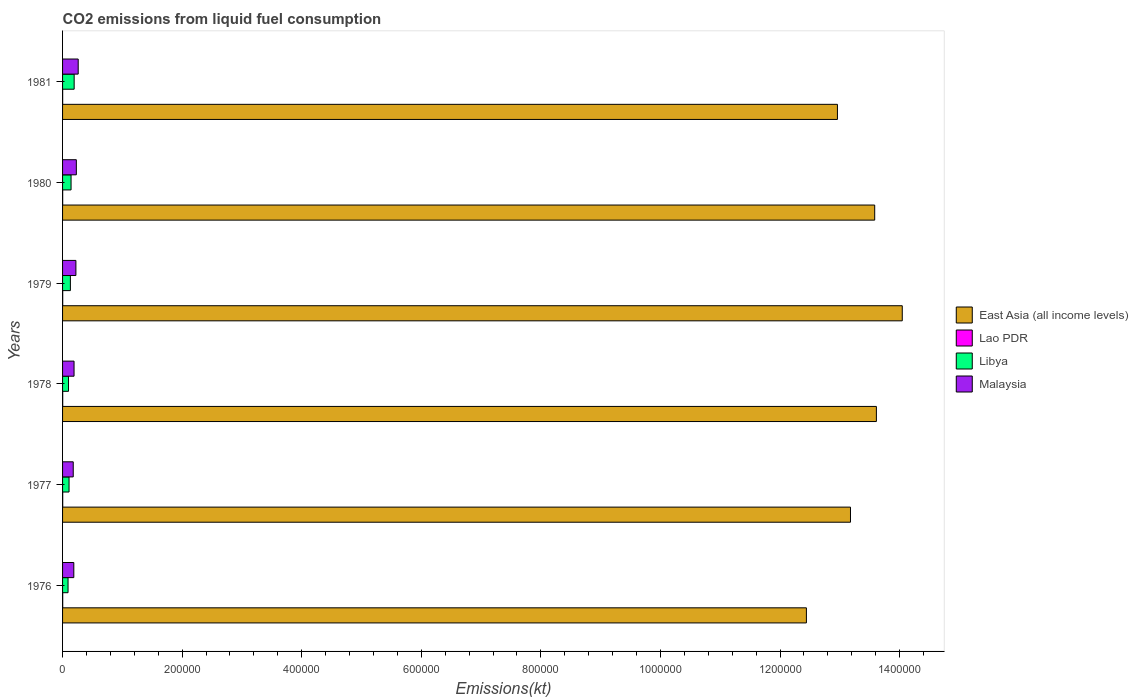How many groups of bars are there?
Ensure brevity in your answer.  6. Are the number of bars per tick equal to the number of legend labels?
Offer a very short reply. Yes. How many bars are there on the 4th tick from the top?
Ensure brevity in your answer.  4. What is the label of the 5th group of bars from the top?
Give a very brief answer. 1977. What is the amount of CO2 emitted in Malaysia in 1981?
Your response must be concise. 2.61e+04. Across all years, what is the maximum amount of CO2 emitted in Malaysia?
Ensure brevity in your answer.  2.61e+04. Across all years, what is the minimum amount of CO2 emitted in East Asia (all income levels)?
Make the answer very short. 1.24e+06. In which year was the amount of CO2 emitted in Libya maximum?
Offer a terse response. 1981. In which year was the amount of CO2 emitted in Libya minimum?
Provide a short and direct response. 1976. What is the total amount of CO2 emitted in Libya in the graph?
Provide a short and direct response. 7.66e+04. What is the difference between the amount of CO2 emitted in Malaysia in 1976 and that in 1981?
Provide a succinct answer. -7330.33. What is the difference between the amount of CO2 emitted in East Asia (all income levels) in 1981 and the amount of CO2 emitted in Lao PDR in 1980?
Offer a very short reply. 1.30e+06. What is the average amount of CO2 emitted in Malaysia per year?
Your answer should be very brief. 2.12e+04. In the year 1977, what is the difference between the amount of CO2 emitted in Libya and amount of CO2 emitted in Lao PDR?
Offer a very short reply. 1.06e+04. In how many years, is the amount of CO2 emitted in East Asia (all income levels) greater than 480000 kt?
Make the answer very short. 6. What is the ratio of the amount of CO2 emitted in Libya in 1977 to that in 1979?
Keep it short and to the point. 0.83. Is the difference between the amount of CO2 emitted in Libya in 1976 and 1980 greater than the difference between the amount of CO2 emitted in Lao PDR in 1976 and 1980?
Make the answer very short. No. What is the difference between the highest and the lowest amount of CO2 emitted in Lao PDR?
Provide a succinct answer. 80.67. In how many years, is the amount of CO2 emitted in Lao PDR greater than the average amount of CO2 emitted in Lao PDR taken over all years?
Your answer should be compact. 4. Is it the case that in every year, the sum of the amount of CO2 emitted in East Asia (all income levels) and amount of CO2 emitted in Malaysia is greater than the sum of amount of CO2 emitted in Libya and amount of CO2 emitted in Lao PDR?
Your answer should be very brief. Yes. What does the 3rd bar from the top in 1979 represents?
Ensure brevity in your answer.  Lao PDR. What does the 2nd bar from the bottom in 1978 represents?
Provide a succinct answer. Lao PDR. Is it the case that in every year, the sum of the amount of CO2 emitted in Malaysia and amount of CO2 emitted in Libya is greater than the amount of CO2 emitted in East Asia (all income levels)?
Your response must be concise. No. Does the graph contain grids?
Your response must be concise. No. Where does the legend appear in the graph?
Offer a terse response. Center right. What is the title of the graph?
Your answer should be very brief. CO2 emissions from liquid fuel consumption. What is the label or title of the X-axis?
Provide a short and direct response. Emissions(kt). What is the Emissions(kt) in East Asia (all income levels) in 1976?
Keep it short and to the point. 1.24e+06. What is the Emissions(kt) of Lao PDR in 1976?
Provide a short and direct response. 223.69. What is the Emissions(kt) of Libya in 1976?
Provide a succinct answer. 9160.17. What is the Emissions(kt) in Malaysia in 1976?
Your answer should be compact. 1.88e+04. What is the Emissions(kt) of East Asia (all income levels) in 1977?
Provide a succinct answer. 1.32e+06. What is the Emissions(kt) in Lao PDR in 1977?
Your response must be concise. 231.02. What is the Emissions(kt) in Libya in 1977?
Make the answer very short. 1.08e+04. What is the Emissions(kt) in Malaysia in 1977?
Offer a terse response. 1.78e+04. What is the Emissions(kt) of East Asia (all income levels) in 1978?
Give a very brief answer. 1.36e+06. What is the Emissions(kt) of Lao PDR in 1978?
Give a very brief answer. 231.02. What is the Emissions(kt) in Libya in 1978?
Your answer should be very brief. 9952.24. What is the Emissions(kt) in Malaysia in 1978?
Your answer should be compact. 1.92e+04. What is the Emissions(kt) in East Asia (all income levels) in 1979?
Your response must be concise. 1.40e+06. What is the Emissions(kt) in Lao PDR in 1979?
Provide a short and direct response. 223.69. What is the Emissions(kt) of Libya in 1979?
Ensure brevity in your answer.  1.31e+04. What is the Emissions(kt) of Malaysia in 1979?
Your response must be concise. 2.23e+04. What is the Emissions(kt) of East Asia (all income levels) in 1980?
Provide a short and direct response. 1.36e+06. What is the Emissions(kt) of Lao PDR in 1980?
Provide a succinct answer. 187.02. What is the Emissions(kt) of Libya in 1980?
Offer a very short reply. 1.42e+04. What is the Emissions(kt) of Malaysia in 1980?
Provide a succinct answer. 2.30e+04. What is the Emissions(kt) of East Asia (all income levels) in 1981?
Your answer should be compact. 1.30e+06. What is the Emissions(kt) of Lao PDR in 1981?
Your response must be concise. 150.35. What is the Emissions(kt) of Libya in 1981?
Give a very brief answer. 1.94e+04. What is the Emissions(kt) of Malaysia in 1981?
Make the answer very short. 2.61e+04. Across all years, what is the maximum Emissions(kt) of East Asia (all income levels)?
Give a very brief answer. 1.40e+06. Across all years, what is the maximum Emissions(kt) of Lao PDR?
Your answer should be very brief. 231.02. Across all years, what is the maximum Emissions(kt) in Libya?
Offer a very short reply. 1.94e+04. Across all years, what is the maximum Emissions(kt) of Malaysia?
Your answer should be compact. 2.61e+04. Across all years, what is the minimum Emissions(kt) in East Asia (all income levels)?
Offer a very short reply. 1.24e+06. Across all years, what is the minimum Emissions(kt) of Lao PDR?
Provide a succinct answer. 150.35. Across all years, what is the minimum Emissions(kt) of Libya?
Keep it short and to the point. 9160.17. Across all years, what is the minimum Emissions(kt) in Malaysia?
Provide a short and direct response. 1.78e+04. What is the total Emissions(kt) of East Asia (all income levels) in the graph?
Make the answer very short. 7.98e+06. What is the total Emissions(kt) in Lao PDR in the graph?
Your answer should be very brief. 1246.78. What is the total Emissions(kt) of Libya in the graph?
Your answer should be compact. 7.66e+04. What is the total Emissions(kt) of Malaysia in the graph?
Provide a short and direct response. 1.27e+05. What is the difference between the Emissions(kt) of East Asia (all income levels) in 1976 and that in 1977?
Provide a short and direct response. -7.37e+04. What is the difference between the Emissions(kt) of Lao PDR in 1976 and that in 1977?
Your answer should be very brief. -7.33. What is the difference between the Emissions(kt) of Libya in 1976 and that in 1977?
Your answer should be compact. -1668.48. What is the difference between the Emissions(kt) in Malaysia in 1976 and that in 1977?
Make the answer very short. 975.42. What is the difference between the Emissions(kt) in East Asia (all income levels) in 1976 and that in 1978?
Provide a succinct answer. -1.17e+05. What is the difference between the Emissions(kt) of Lao PDR in 1976 and that in 1978?
Offer a terse response. -7.33. What is the difference between the Emissions(kt) in Libya in 1976 and that in 1978?
Provide a succinct answer. -792.07. What is the difference between the Emissions(kt) of Malaysia in 1976 and that in 1978?
Your response must be concise. -392.37. What is the difference between the Emissions(kt) in East Asia (all income levels) in 1976 and that in 1979?
Your answer should be compact. -1.60e+05. What is the difference between the Emissions(kt) in Lao PDR in 1976 and that in 1979?
Offer a terse response. 0. What is the difference between the Emissions(kt) in Libya in 1976 and that in 1979?
Provide a succinct answer. -3920.02. What is the difference between the Emissions(kt) of Malaysia in 1976 and that in 1979?
Offer a very short reply. -3494.65. What is the difference between the Emissions(kt) of East Asia (all income levels) in 1976 and that in 1980?
Provide a succinct answer. -1.14e+05. What is the difference between the Emissions(kt) in Lao PDR in 1976 and that in 1980?
Ensure brevity in your answer.  36.67. What is the difference between the Emissions(kt) in Libya in 1976 and that in 1980?
Ensure brevity in your answer.  -5049.46. What is the difference between the Emissions(kt) of Malaysia in 1976 and that in 1980?
Provide a succinct answer. -4228.05. What is the difference between the Emissions(kt) of East Asia (all income levels) in 1976 and that in 1981?
Give a very brief answer. -5.19e+04. What is the difference between the Emissions(kt) of Lao PDR in 1976 and that in 1981?
Your response must be concise. 73.34. What is the difference between the Emissions(kt) in Libya in 1976 and that in 1981?
Your answer should be very brief. -1.02e+04. What is the difference between the Emissions(kt) of Malaysia in 1976 and that in 1981?
Make the answer very short. -7330.33. What is the difference between the Emissions(kt) of East Asia (all income levels) in 1977 and that in 1978?
Your answer should be very brief. -4.33e+04. What is the difference between the Emissions(kt) in Lao PDR in 1977 and that in 1978?
Provide a succinct answer. 0. What is the difference between the Emissions(kt) of Libya in 1977 and that in 1978?
Make the answer very short. 876.41. What is the difference between the Emissions(kt) of Malaysia in 1977 and that in 1978?
Offer a terse response. -1367.79. What is the difference between the Emissions(kt) of East Asia (all income levels) in 1977 and that in 1979?
Your answer should be compact. -8.66e+04. What is the difference between the Emissions(kt) of Lao PDR in 1977 and that in 1979?
Make the answer very short. 7.33. What is the difference between the Emissions(kt) of Libya in 1977 and that in 1979?
Offer a terse response. -2251.54. What is the difference between the Emissions(kt) in Malaysia in 1977 and that in 1979?
Give a very brief answer. -4470.07. What is the difference between the Emissions(kt) of East Asia (all income levels) in 1977 and that in 1980?
Your answer should be compact. -4.05e+04. What is the difference between the Emissions(kt) in Lao PDR in 1977 and that in 1980?
Keep it short and to the point. 44. What is the difference between the Emissions(kt) in Libya in 1977 and that in 1980?
Ensure brevity in your answer.  -3380.97. What is the difference between the Emissions(kt) in Malaysia in 1977 and that in 1980?
Offer a very short reply. -5203.47. What is the difference between the Emissions(kt) of East Asia (all income levels) in 1977 and that in 1981?
Ensure brevity in your answer.  2.18e+04. What is the difference between the Emissions(kt) in Lao PDR in 1977 and that in 1981?
Offer a terse response. 80.67. What is the difference between the Emissions(kt) in Libya in 1977 and that in 1981?
Provide a succinct answer. -8562.44. What is the difference between the Emissions(kt) in Malaysia in 1977 and that in 1981?
Your answer should be compact. -8305.75. What is the difference between the Emissions(kt) of East Asia (all income levels) in 1978 and that in 1979?
Provide a succinct answer. -4.33e+04. What is the difference between the Emissions(kt) of Lao PDR in 1978 and that in 1979?
Offer a terse response. 7.33. What is the difference between the Emissions(kt) of Libya in 1978 and that in 1979?
Keep it short and to the point. -3127.95. What is the difference between the Emissions(kt) in Malaysia in 1978 and that in 1979?
Offer a terse response. -3102.28. What is the difference between the Emissions(kt) of East Asia (all income levels) in 1978 and that in 1980?
Ensure brevity in your answer.  2812.53. What is the difference between the Emissions(kt) of Lao PDR in 1978 and that in 1980?
Offer a terse response. 44. What is the difference between the Emissions(kt) of Libya in 1978 and that in 1980?
Offer a terse response. -4257.39. What is the difference between the Emissions(kt) in Malaysia in 1978 and that in 1980?
Offer a very short reply. -3835.68. What is the difference between the Emissions(kt) in East Asia (all income levels) in 1978 and that in 1981?
Keep it short and to the point. 6.51e+04. What is the difference between the Emissions(kt) in Lao PDR in 1978 and that in 1981?
Provide a succinct answer. 80.67. What is the difference between the Emissions(kt) of Libya in 1978 and that in 1981?
Your answer should be compact. -9438.86. What is the difference between the Emissions(kt) in Malaysia in 1978 and that in 1981?
Keep it short and to the point. -6937.96. What is the difference between the Emissions(kt) in East Asia (all income levels) in 1979 and that in 1980?
Provide a short and direct response. 4.61e+04. What is the difference between the Emissions(kt) of Lao PDR in 1979 and that in 1980?
Provide a short and direct response. 36.67. What is the difference between the Emissions(kt) in Libya in 1979 and that in 1980?
Give a very brief answer. -1129.44. What is the difference between the Emissions(kt) of Malaysia in 1979 and that in 1980?
Provide a short and direct response. -733.4. What is the difference between the Emissions(kt) of East Asia (all income levels) in 1979 and that in 1981?
Provide a short and direct response. 1.08e+05. What is the difference between the Emissions(kt) in Lao PDR in 1979 and that in 1981?
Your answer should be compact. 73.34. What is the difference between the Emissions(kt) in Libya in 1979 and that in 1981?
Your answer should be very brief. -6310.91. What is the difference between the Emissions(kt) in Malaysia in 1979 and that in 1981?
Make the answer very short. -3835.68. What is the difference between the Emissions(kt) of East Asia (all income levels) in 1980 and that in 1981?
Provide a short and direct response. 6.23e+04. What is the difference between the Emissions(kt) of Lao PDR in 1980 and that in 1981?
Ensure brevity in your answer.  36.67. What is the difference between the Emissions(kt) in Libya in 1980 and that in 1981?
Your answer should be compact. -5181.47. What is the difference between the Emissions(kt) of Malaysia in 1980 and that in 1981?
Give a very brief answer. -3102.28. What is the difference between the Emissions(kt) of East Asia (all income levels) in 1976 and the Emissions(kt) of Lao PDR in 1977?
Give a very brief answer. 1.24e+06. What is the difference between the Emissions(kt) of East Asia (all income levels) in 1976 and the Emissions(kt) of Libya in 1977?
Provide a short and direct response. 1.23e+06. What is the difference between the Emissions(kt) of East Asia (all income levels) in 1976 and the Emissions(kt) of Malaysia in 1977?
Offer a terse response. 1.23e+06. What is the difference between the Emissions(kt) of Lao PDR in 1976 and the Emissions(kt) of Libya in 1977?
Provide a succinct answer. -1.06e+04. What is the difference between the Emissions(kt) in Lao PDR in 1976 and the Emissions(kt) in Malaysia in 1977?
Give a very brief answer. -1.76e+04. What is the difference between the Emissions(kt) in Libya in 1976 and the Emissions(kt) in Malaysia in 1977?
Your answer should be compact. -8683.46. What is the difference between the Emissions(kt) in East Asia (all income levels) in 1976 and the Emissions(kt) in Lao PDR in 1978?
Ensure brevity in your answer.  1.24e+06. What is the difference between the Emissions(kt) of East Asia (all income levels) in 1976 and the Emissions(kt) of Libya in 1978?
Your answer should be very brief. 1.23e+06. What is the difference between the Emissions(kt) of East Asia (all income levels) in 1976 and the Emissions(kt) of Malaysia in 1978?
Your answer should be very brief. 1.22e+06. What is the difference between the Emissions(kt) in Lao PDR in 1976 and the Emissions(kt) in Libya in 1978?
Offer a very short reply. -9728.55. What is the difference between the Emissions(kt) in Lao PDR in 1976 and the Emissions(kt) in Malaysia in 1978?
Give a very brief answer. -1.90e+04. What is the difference between the Emissions(kt) in Libya in 1976 and the Emissions(kt) in Malaysia in 1978?
Your answer should be very brief. -1.01e+04. What is the difference between the Emissions(kt) in East Asia (all income levels) in 1976 and the Emissions(kt) in Lao PDR in 1979?
Ensure brevity in your answer.  1.24e+06. What is the difference between the Emissions(kt) of East Asia (all income levels) in 1976 and the Emissions(kt) of Libya in 1979?
Your answer should be very brief. 1.23e+06. What is the difference between the Emissions(kt) in East Asia (all income levels) in 1976 and the Emissions(kt) in Malaysia in 1979?
Your answer should be very brief. 1.22e+06. What is the difference between the Emissions(kt) of Lao PDR in 1976 and the Emissions(kt) of Libya in 1979?
Provide a short and direct response. -1.29e+04. What is the difference between the Emissions(kt) in Lao PDR in 1976 and the Emissions(kt) in Malaysia in 1979?
Ensure brevity in your answer.  -2.21e+04. What is the difference between the Emissions(kt) in Libya in 1976 and the Emissions(kt) in Malaysia in 1979?
Offer a terse response. -1.32e+04. What is the difference between the Emissions(kt) of East Asia (all income levels) in 1976 and the Emissions(kt) of Lao PDR in 1980?
Your answer should be very brief. 1.24e+06. What is the difference between the Emissions(kt) in East Asia (all income levels) in 1976 and the Emissions(kt) in Libya in 1980?
Your answer should be compact. 1.23e+06. What is the difference between the Emissions(kt) of East Asia (all income levels) in 1976 and the Emissions(kt) of Malaysia in 1980?
Give a very brief answer. 1.22e+06. What is the difference between the Emissions(kt) in Lao PDR in 1976 and the Emissions(kt) in Libya in 1980?
Your answer should be very brief. -1.40e+04. What is the difference between the Emissions(kt) in Lao PDR in 1976 and the Emissions(kt) in Malaysia in 1980?
Your answer should be very brief. -2.28e+04. What is the difference between the Emissions(kt) in Libya in 1976 and the Emissions(kt) in Malaysia in 1980?
Provide a short and direct response. -1.39e+04. What is the difference between the Emissions(kt) of East Asia (all income levels) in 1976 and the Emissions(kt) of Lao PDR in 1981?
Give a very brief answer. 1.24e+06. What is the difference between the Emissions(kt) of East Asia (all income levels) in 1976 and the Emissions(kt) of Libya in 1981?
Make the answer very short. 1.22e+06. What is the difference between the Emissions(kt) of East Asia (all income levels) in 1976 and the Emissions(kt) of Malaysia in 1981?
Give a very brief answer. 1.22e+06. What is the difference between the Emissions(kt) of Lao PDR in 1976 and the Emissions(kt) of Libya in 1981?
Provide a short and direct response. -1.92e+04. What is the difference between the Emissions(kt) in Lao PDR in 1976 and the Emissions(kt) in Malaysia in 1981?
Provide a succinct answer. -2.59e+04. What is the difference between the Emissions(kt) of Libya in 1976 and the Emissions(kt) of Malaysia in 1981?
Provide a succinct answer. -1.70e+04. What is the difference between the Emissions(kt) of East Asia (all income levels) in 1977 and the Emissions(kt) of Lao PDR in 1978?
Your response must be concise. 1.32e+06. What is the difference between the Emissions(kt) in East Asia (all income levels) in 1977 and the Emissions(kt) in Libya in 1978?
Provide a succinct answer. 1.31e+06. What is the difference between the Emissions(kt) of East Asia (all income levels) in 1977 and the Emissions(kt) of Malaysia in 1978?
Your answer should be very brief. 1.30e+06. What is the difference between the Emissions(kt) of Lao PDR in 1977 and the Emissions(kt) of Libya in 1978?
Your answer should be compact. -9721.22. What is the difference between the Emissions(kt) in Lao PDR in 1977 and the Emissions(kt) in Malaysia in 1978?
Provide a short and direct response. -1.90e+04. What is the difference between the Emissions(kt) of Libya in 1977 and the Emissions(kt) of Malaysia in 1978?
Make the answer very short. -8382.76. What is the difference between the Emissions(kt) of East Asia (all income levels) in 1977 and the Emissions(kt) of Lao PDR in 1979?
Make the answer very short. 1.32e+06. What is the difference between the Emissions(kt) in East Asia (all income levels) in 1977 and the Emissions(kt) in Libya in 1979?
Provide a succinct answer. 1.30e+06. What is the difference between the Emissions(kt) of East Asia (all income levels) in 1977 and the Emissions(kt) of Malaysia in 1979?
Provide a succinct answer. 1.30e+06. What is the difference between the Emissions(kt) in Lao PDR in 1977 and the Emissions(kt) in Libya in 1979?
Offer a very short reply. -1.28e+04. What is the difference between the Emissions(kt) of Lao PDR in 1977 and the Emissions(kt) of Malaysia in 1979?
Your answer should be very brief. -2.21e+04. What is the difference between the Emissions(kt) of Libya in 1977 and the Emissions(kt) of Malaysia in 1979?
Provide a short and direct response. -1.15e+04. What is the difference between the Emissions(kt) in East Asia (all income levels) in 1977 and the Emissions(kt) in Lao PDR in 1980?
Make the answer very short. 1.32e+06. What is the difference between the Emissions(kt) in East Asia (all income levels) in 1977 and the Emissions(kt) in Libya in 1980?
Offer a terse response. 1.30e+06. What is the difference between the Emissions(kt) in East Asia (all income levels) in 1977 and the Emissions(kt) in Malaysia in 1980?
Offer a very short reply. 1.29e+06. What is the difference between the Emissions(kt) in Lao PDR in 1977 and the Emissions(kt) in Libya in 1980?
Provide a short and direct response. -1.40e+04. What is the difference between the Emissions(kt) in Lao PDR in 1977 and the Emissions(kt) in Malaysia in 1980?
Your answer should be compact. -2.28e+04. What is the difference between the Emissions(kt) in Libya in 1977 and the Emissions(kt) in Malaysia in 1980?
Your answer should be compact. -1.22e+04. What is the difference between the Emissions(kt) in East Asia (all income levels) in 1977 and the Emissions(kt) in Lao PDR in 1981?
Provide a short and direct response. 1.32e+06. What is the difference between the Emissions(kt) of East Asia (all income levels) in 1977 and the Emissions(kt) of Libya in 1981?
Your answer should be very brief. 1.30e+06. What is the difference between the Emissions(kt) of East Asia (all income levels) in 1977 and the Emissions(kt) of Malaysia in 1981?
Offer a very short reply. 1.29e+06. What is the difference between the Emissions(kt) in Lao PDR in 1977 and the Emissions(kt) in Libya in 1981?
Your response must be concise. -1.92e+04. What is the difference between the Emissions(kt) of Lao PDR in 1977 and the Emissions(kt) of Malaysia in 1981?
Ensure brevity in your answer.  -2.59e+04. What is the difference between the Emissions(kt) of Libya in 1977 and the Emissions(kt) of Malaysia in 1981?
Your response must be concise. -1.53e+04. What is the difference between the Emissions(kt) of East Asia (all income levels) in 1978 and the Emissions(kt) of Lao PDR in 1979?
Your answer should be compact. 1.36e+06. What is the difference between the Emissions(kt) in East Asia (all income levels) in 1978 and the Emissions(kt) in Libya in 1979?
Your response must be concise. 1.35e+06. What is the difference between the Emissions(kt) in East Asia (all income levels) in 1978 and the Emissions(kt) in Malaysia in 1979?
Provide a short and direct response. 1.34e+06. What is the difference between the Emissions(kt) of Lao PDR in 1978 and the Emissions(kt) of Libya in 1979?
Offer a very short reply. -1.28e+04. What is the difference between the Emissions(kt) in Lao PDR in 1978 and the Emissions(kt) in Malaysia in 1979?
Offer a very short reply. -2.21e+04. What is the difference between the Emissions(kt) of Libya in 1978 and the Emissions(kt) of Malaysia in 1979?
Keep it short and to the point. -1.24e+04. What is the difference between the Emissions(kt) in East Asia (all income levels) in 1978 and the Emissions(kt) in Lao PDR in 1980?
Your answer should be very brief. 1.36e+06. What is the difference between the Emissions(kt) of East Asia (all income levels) in 1978 and the Emissions(kt) of Libya in 1980?
Give a very brief answer. 1.35e+06. What is the difference between the Emissions(kt) of East Asia (all income levels) in 1978 and the Emissions(kt) of Malaysia in 1980?
Give a very brief answer. 1.34e+06. What is the difference between the Emissions(kt) of Lao PDR in 1978 and the Emissions(kt) of Libya in 1980?
Provide a short and direct response. -1.40e+04. What is the difference between the Emissions(kt) in Lao PDR in 1978 and the Emissions(kt) in Malaysia in 1980?
Offer a terse response. -2.28e+04. What is the difference between the Emissions(kt) in Libya in 1978 and the Emissions(kt) in Malaysia in 1980?
Provide a short and direct response. -1.31e+04. What is the difference between the Emissions(kt) of East Asia (all income levels) in 1978 and the Emissions(kt) of Lao PDR in 1981?
Give a very brief answer. 1.36e+06. What is the difference between the Emissions(kt) of East Asia (all income levels) in 1978 and the Emissions(kt) of Libya in 1981?
Give a very brief answer. 1.34e+06. What is the difference between the Emissions(kt) of East Asia (all income levels) in 1978 and the Emissions(kt) of Malaysia in 1981?
Give a very brief answer. 1.34e+06. What is the difference between the Emissions(kt) in Lao PDR in 1978 and the Emissions(kt) in Libya in 1981?
Keep it short and to the point. -1.92e+04. What is the difference between the Emissions(kt) of Lao PDR in 1978 and the Emissions(kt) of Malaysia in 1981?
Your response must be concise. -2.59e+04. What is the difference between the Emissions(kt) in Libya in 1978 and the Emissions(kt) in Malaysia in 1981?
Your answer should be compact. -1.62e+04. What is the difference between the Emissions(kt) in East Asia (all income levels) in 1979 and the Emissions(kt) in Lao PDR in 1980?
Keep it short and to the point. 1.40e+06. What is the difference between the Emissions(kt) in East Asia (all income levels) in 1979 and the Emissions(kt) in Libya in 1980?
Offer a very short reply. 1.39e+06. What is the difference between the Emissions(kt) in East Asia (all income levels) in 1979 and the Emissions(kt) in Malaysia in 1980?
Your response must be concise. 1.38e+06. What is the difference between the Emissions(kt) of Lao PDR in 1979 and the Emissions(kt) of Libya in 1980?
Your answer should be very brief. -1.40e+04. What is the difference between the Emissions(kt) of Lao PDR in 1979 and the Emissions(kt) of Malaysia in 1980?
Your answer should be very brief. -2.28e+04. What is the difference between the Emissions(kt) of Libya in 1979 and the Emissions(kt) of Malaysia in 1980?
Offer a very short reply. -9966.91. What is the difference between the Emissions(kt) of East Asia (all income levels) in 1979 and the Emissions(kt) of Lao PDR in 1981?
Provide a succinct answer. 1.40e+06. What is the difference between the Emissions(kt) of East Asia (all income levels) in 1979 and the Emissions(kt) of Libya in 1981?
Offer a very short reply. 1.39e+06. What is the difference between the Emissions(kt) in East Asia (all income levels) in 1979 and the Emissions(kt) in Malaysia in 1981?
Your answer should be very brief. 1.38e+06. What is the difference between the Emissions(kt) in Lao PDR in 1979 and the Emissions(kt) in Libya in 1981?
Your answer should be compact. -1.92e+04. What is the difference between the Emissions(kt) of Lao PDR in 1979 and the Emissions(kt) of Malaysia in 1981?
Ensure brevity in your answer.  -2.59e+04. What is the difference between the Emissions(kt) of Libya in 1979 and the Emissions(kt) of Malaysia in 1981?
Your answer should be very brief. -1.31e+04. What is the difference between the Emissions(kt) in East Asia (all income levels) in 1980 and the Emissions(kt) in Lao PDR in 1981?
Offer a terse response. 1.36e+06. What is the difference between the Emissions(kt) in East Asia (all income levels) in 1980 and the Emissions(kt) in Libya in 1981?
Offer a terse response. 1.34e+06. What is the difference between the Emissions(kt) in East Asia (all income levels) in 1980 and the Emissions(kt) in Malaysia in 1981?
Provide a succinct answer. 1.33e+06. What is the difference between the Emissions(kt) of Lao PDR in 1980 and the Emissions(kt) of Libya in 1981?
Provide a succinct answer. -1.92e+04. What is the difference between the Emissions(kt) in Lao PDR in 1980 and the Emissions(kt) in Malaysia in 1981?
Offer a very short reply. -2.60e+04. What is the difference between the Emissions(kt) of Libya in 1980 and the Emissions(kt) of Malaysia in 1981?
Keep it short and to the point. -1.19e+04. What is the average Emissions(kt) of East Asia (all income levels) per year?
Your answer should be compact. 1.33e+06. What is the average Emissions(kt) of Lao PDR per year?
Give a very brief answer. 207.8. What is the average Emissions(kt) of Libya per year?
Your answer should be compact. 1.28e+04. What is the average Emissions(kt) in Malaysia per year?
Offer a terse response. 2.12e+04. In the year 1976, what is the difference between the Emissions(kt) of East Asia (all income levels) and Emissions(kt) of Lao PDR?
Give a very brief answer. 1.24e+06. In the year 1976, what is the difference between the Emissions(kt) in East Asia (all income levels) and Emissions(kt) in Libya?
Offer a terse response. 1.23e+06. In the year 1976, what is the difference between the Emissions(kt) in East Asia (all income levels) and Emissions(kt) in Malaysia?
Give a very brief answer. 1.23e+06. In the year 1976, what is the difference between the Emissions(kt) in Lao PDR and Emissions(kt) in Libya?
Give a very brief answer. -8936.48. In the year 1976, what is the difference between the Emissions(kt) of Lao PDR and Emissions(kt) of Malaysia?
Make the answer very short. -1.86e+04. In the year 1976, what is the difference between the Emissions(kt) in Libya and Emissions(kt) in Malaysia?
Make the answer very short. -9658.88. In the year 1977, what is the difference between the Emissions(kt) of East Asia (all income levels) and Emissions(kt) of Lao PDR?
Your answer should be compact. 1.32e+06. In the year 1977, what is the difference between the Emissions(kt) of East Asia (all income levels) and Emissions(kt) of Libya?
Give a very brief answer. 1.31e+06. In the year 1977, what is the difference between the Emissions(kt) in East Asia (all income levels) and Emissions(kt) in Malaysia?
Provide a short and direct response. 1.30e+06. In the year 1977, what is the difference between the Emissions(kt) in Lao PDR and Emissions(kt) in Libya?
Keep it short and to the point. -1.06e+04. In the year 1977, what is the difference between the Emissions(kt) in Lao PDR and Emissions(kt) in Malaysia?
Your answer should be compact. -1.76e+04. In the year 1977, what is the difference between the Emissions(kt) in Libya and Emissions(kt) in Malaysia?
Provide a short and direct response. -7014.97. In the year 1978, what is the difference between the Emissions(kt) in East Asia (all income levels) and Emissions(kt) in Lao PDR?
Your answer should be very brief. 1.36e+06. In the year 1978, what is the difference between the Emissions(kt) of East Asia (all income levels) and Emissions(kt) of Libya?
Your answer should be very brief. 1.35e+06. In the year 1978, what is the difference between the Emissions(kt) of East Asia (all income levels) and Emissions(kt) of Malaysia?
Offer a terse response. 1.34e+06. In the year 1978, what is the difference between the Emissions(kt) of Lao PDR and Emissions(kt) of Libya?
Provide a succinct answer. -9721.22. In the year 1978, what is the difference between the Emissions(kt) in Lao PDR and Emissions(kt) in Malaysia?
Offer a very short reply. -1.90e+04. In the year 1978, what is the difference between the Emissions(kt) of Libya and Emissions(kt) of Malaysia?
Your response must be concise. -9259.17. In the year 1979, what is the difference between the Emissions(kt) of East Asia (all income levels) and Emissions(kt) of Lao PDR?
Give a very brief answer. 1.40e+06. In the year 1979, what is the difference between the Emissions(kt) in East Asia (all income levels) and Emissions(kt) in Libya?
Keep it short and to the point. 1.39e+06. In the year 1979, what is the difference between the Emissions(kt) of East Asia (all income levels) and Emissions(kt) of Malaysia?
Your answer should be compact. 1.38e+06. In the year 1979, what is the difference between the Emissions(kt) of Lao PDR and Emissions(kt) of Libya?
Make the answer very short. -1.29e+04. In the year 1979, what is the difference between the Emissions(kt) in Lao PDR and Emissions(kt) in Malaysia?
Provide a succinct answer. -2.21e+04. In the year 1979, what is the difference between the Emissions(kt) in Libya and Emissions(kt) in Malaysia?
Provide a succinct answer. -9233.51. In the year 1980, what is the difference between the Emissions(kt) in East Asia (all income levels) and Emissions(kt) in Lao PDR?
Ensure brevity in your answer.  1.36e+06. In the year 1980, what is the difference between the Emissions(kt) in East Asia (all income levels) and Emissions(kt) in Libya?
Keep it short and to the point. 1.34e+06. In the year 1980, what is the difference between the Emissions(kt) in East Asia (all income levels) and Emissions(kt) in Malaysia?
Your response must be concise. 1.34e+06. In the year 1980, what is the difference between the Emissions(kt) of Lao PDR and Emissions(kt) of Libya?
Provide a succinct answer. -1.40e+04. In the year 1980, what is the difference between the Emissions(kt) in Lao PDR and Emissions(kt) in Malaysia?
Your response must be concise. -2.29e+04. In the year 1980, what is the difference between the Emissions(kt) in Libya and Emissions(kt) in Malaysia?
Keep it short and to the point. -8837.47. In the year 1981, what is the difference between the Emissions(kt) in East Asia (all income levels) and Emissions(kt) in Lao PDR?
Your answer should be compact. 1.30e+06. In the year 1981, what is the difference between the Emissions(kt) in East Asia (all income levels) and Emissions(kt) in Libya?
Offer a terse response. 1.28e+06. In the year 1981, what is the difference between the Emissions(kt) of East Asia (all income levels) and Emissions(kt) of Malaysia?
Provide a succinct answer. 1.27e+06. In the year 1981, what is the difference between the Emissions(kt) of Lao PDR and Emissions(kt) of Libya?
Offer a terse response. -1.92e+04. In the year 1981, what is the difference between the Emissions(kt) of Lao PDR and Emissions(kt) of Malaysia?
Your response must be concise. -2.60e+04. In the year 1981, what is the difference between the Emissions(kt) of Libya and Emissions(kt) of Malaysia?
Provide a short and direct response. -6758.28. What is the ratio of the Emissions(kt) in East Asia (all income levels) in 1976 to that in 1977?
Make the answer very short. 0.94. What is the ratio of the Emissions(kt) of Lao PDR in 1976 to that in 1977?
Make the answer very short. 0.97. What is the ratio of the Emissions(kt) in Libya in 1976 to that in 1977?
Keep it short and to the point. 0.85. What is the ratio of the Emissions(kt) of Malaysia in 1976 to that in 1977?
Make the answer very short. 1.05. What is the ratio of the Emissions(kt) of East Asia (all income levels) in 1976 to that in 1978?
Keep it short and to the point. 0.91. What is the ratio of the Emissions(kt) in Lao PDR in 1976 to that in 1978?
Ensure brevity in your answer.  0.97. What is the ratio of the Emissions(kt) in Libya in 1976 to that in 1978?
Keep it short and to the point. 0.92. What is the ratio of the Emissions(kt) in Malaysia in 1976 to that in 1978?
Your response must be concise. 0.98. What is the ratio of the Emissions(kt) of East Asia (all income levels) in 1976 to that in 1979?
Give a very brief answer. 0.89. What is the ratio of the Emissions(kt) of Lao PDR in 1976 to that in 1979?
Your answer should be compact. 1. What is the ratio of the Emissions(kt) in Libya in 1976 to that in 1979?
Give a very brief answer. 0.7. What is the ratio of the Emissions(kt) of Malaysia in 1976 to that in 1979?
Offer a terse response. 0.84. What is the ratio of the Emissions(kt) in East Asia (all income levels) in 1976 to that in 1980?
Keep it short and to the point. 0.92. What is the ratio of the Emissions(kt) of Lao PDR in 1976 to that in 1980?
Offer a very short reply. 1.2. What is the ratio of the Emissions(kt) in Libya in 1976 to that in 1980?
Make the answer very short. 0.64. What is the ratio of the Emissions(kt) of Malaysia in 1976 to that in 1980?
Give a very brief answer. 0.82. What is the ratio of the Emissions(kt) of Lao PDR in 1976 to that in 1981?
Your response must be concise. 1.49. What is the ratio of the Emissions(kt) in Libya in 1976 to that in 1981?
Your answer should be very brief. 0.47. What is the ratio of the Emissions(kt) of Malaysia in 1976 to that in 1981?
Offer a very short reply. 0.72. What is the ratio of the Emissions(kt) in East Asia (all income levels) in 1977 to that in 1978?
Make the answer very short. 0.97. What is the ratio of the Emissions(kt) in Libya in 1977 to that in 1978?
Give a very brief answer. 1.09. What is the ratio of the Emissions(kt) of Malaysia in 1977 to that in 1978?
Provide a short and direct response. 0.93. What is the ratio of the Emissions(kt) of East Asia (all income levels) in 1977 to that in 1979?
Give a very brief answer. 0.94. What is the ratio of the Emissions(kt) in Lao PDR in 1977 to that in 1979?
Keep it short and to the point. 1.03. What is the ratio of the Emissions(kt) of Libya in 1977 to that in 1979?
Offer a terse response. 0.83. What is the ratio of the Emissions(kt) in Malaysia in 1977 to that in 1979?
Make the answer very short. 0.8. What is the ratio of the Emissions(kt) in East Asia (all income levels) in 1977 to that in 1980?
Offer a terse response. 0.97. What is the ratio of the Emissions(kt) in Lao PDR in 1977 to that in 1980?
Make the answer very short. 1.24. What is the ratio of the Emissions(kt) of Libya in 1977 to that in 1980?
Provide a succinct answer. 0.76. What is the ratio of the Emissions(kt) in Malaysia in 1977 to that in 1980?
Your answer should be compact. 0.77. What is the ratio of the Emissions(kt) of East Asia (all income levels) in 1977 to that in 1981?
Offer a terse response. 1.02. What is the ratio of the Emissions(kt) of Lao PDR in 1977 to that in 1981?
Ensure brevity in your answer.  1.54. What is the ratio of the Emissions(kt) in Libya in 1977 to that in 1981?
Offer a very short reply. 0.56. What is the ratio of the Emissions(kt) in Malaysia in 1977 to that in 1981?
Offer a very short reply. 0.68. What is the ratio of the Emissions(kt) of East Asia (all income levels) in 1978 to that in 1979?
Ensure brevity in your answer.  0.97. What is the ratio of the Emissions(kt) in Lao PDR in 1978 to that in 1979?
Provide a succinct answer. 1.03. What is the ratio of the Emissions(kt) of Libya in 1978 to that in 1979?
Ensure brevity in your answer.  0.76. What is the ratio of the Emissions(kt) in Malaysia in 1978 to that in 1979?
Your response must be concise. 0.86. What is the ratio of the Emissions(kt) of East Asia (all income levels) in 1978 to that in 1980?
Ensure brevity in your answer.  1. What is the ratio of the Emissions(kt) in Lao PDR in 1978 to that in 1980?
Provide a succinct answer. 1.24. What is the ratio of the Emissions(kt) of Libya in 1978 to that in 1980?
Keep it short and to the point. 0.7. What is the ratio of the Emissions(kt) in Malaysia in 1978 to that in 1980?
Your answer should be compact. 0.83. What is the ratio of the Emissions(kt) of East Asia (all income levels) in 1978 to that in 1981?
Keep it short and to the point. 1.05. What is the ratio of the Emissions(kt) of Lao PDR in 1978 to that in 1981?
Provide a succinct answer. 1.54. What is the ratio of the Emissions(kt) in Libya in 1978 to that in 1981?
Provide a succinct answer. 0.51. What is the ratio of the Emissions(kt) of Malaysia in 1978 to that in 1981?
Make the answer very short. 0.73. What is the ratio of the Emissions(kt) in East Asia (all income levels) in 1979 to that in 1980?
Provide a succinct answer. 1.03. What is the ratio of the Emissions(kt) in Lao PDR in 1979 to that in 1980?
Your response must be concise. 1.2. What is the ratio of the Emissions(kt) in Libya in 1979 to that in 1980?
Ensure brevity in your answer.  0.92. What is the ratio of the Emissions(kt) in Malaysia in 1979 to that in 1980?
Your answer should be compact. 0.97. What is the ratio of the Emissions(kt) of East Asia (all income levels) in 1979 to that in 1981?
Make the answer very short. 1.08. What is the ratio of the Emissions(kt) of Lao PDR in 1979 to that in 1981?
Offer a terse response. 1.49. What is the ratio of the Emissions(kt) of Libya in 1979 to that in 1981?
Provide a short and direct response. 0.67. What is the ratio of the Emissions(kt) of Malaysia in 1979 to that in 1981?
Offer a terse response. 0.85. What is the ratio of the Emissions(kt) in East Asia (all income levels) in 1980 to that in 1981?
Give a very brief answer. 1.05. What is the ratio of the Emissions(kt) in Lao PDR in 1980 to that in 1981?
Ensure brevity in your answer.  1.24. What is the ratio of the Emissions(kt) in Libya in 1980 to that in 1981?
Your response must be concise. 0.73. What is the ratio of the Emissions(kt) in Malaysia in 1980 to that in 1981?
Ensure brevity in your answer.  0.88. What is the difference between the highest and the second highest Emissions(kt) of East Asia (all income levels)?
Keep it short and to the point. 4.33e+04. What is the difference between the highest and the second highest Emissions(kt) of Lao PDR?
Your answer should be very brief. 0. What is the difference between the highest and the second highest Emissions(kt) in Libya?
Ensure brevity in your answer.  5181.47. What is the difference between the highest and the second highest Emissions(kt) of Malaysia?
Keep it short and to the point. 3102.28. What is the difference between the highest and the lowest Emissions(kt) in East Asia (all income levels)?
Offer a terse response. 1.60e+05. What is the difference between the highest and the lowest Emissions(kt) in Lao PDR?
Offer a very short reply. 80.67. What is the difference between the highest and the lowest Emissions(kt) in Libya?
Your answer should be compact. 1.02e+04. What is the difference between the highest and the lowest Emissions(kt) of Malaysia?
Your answer should be compact. 8305.75. 